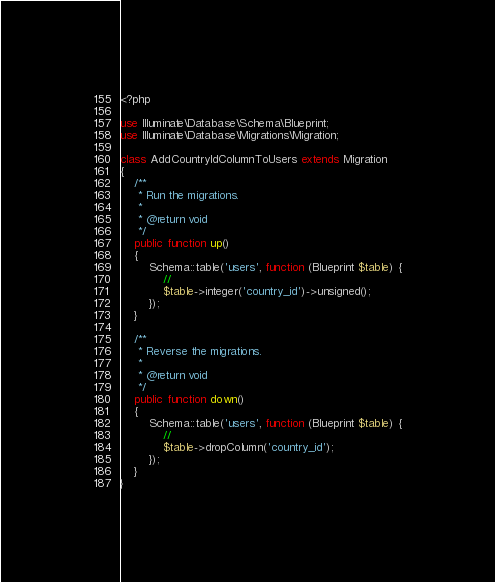Convert code to text. <code><loc_0><loc_0><loc_500><loc_500><_PHP_><?php

use Illuminate\Database\Schema\Blueprint;
use Illuminate\Database\Migrations\Migration;

class AddCountryIdColumnToUsers extends Migration
{
    /**
     * Run the migrations.
     *
     * @return void
     */
    public function up()
    {
        Schema::table('users', function (Blueprint $table) {
            //
            $table->integer('country_id')->unsigned();
        });
    }

    /**
     * Reverse the migrations.
     *
     * @return void
     */
    public function down()
    {
        Schema::table('users', function (Blueprint $table) {
            //
            $table->dropColumn('country_id');
        });
    }
}
</code> 